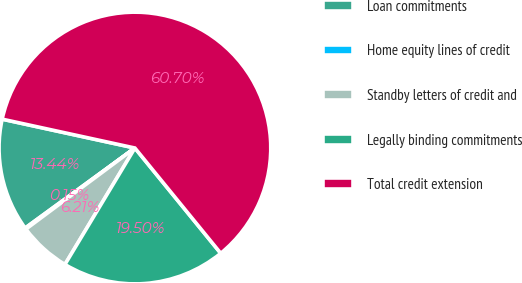Convert chart. <chart><loc_0><loc_0><loc_500><loc_500><pie_chart><fcel>Loan commitments<fcel>Home equity lines of credit<fcel>Standby letters of credit and<fcel>Legally binding commitments<fcel>Total credit extension<nl><fcel>13.44%<fcel>0.15%<fcel>6.21%<fcel>19.5%<fcel>60.71%<nl></chart> 